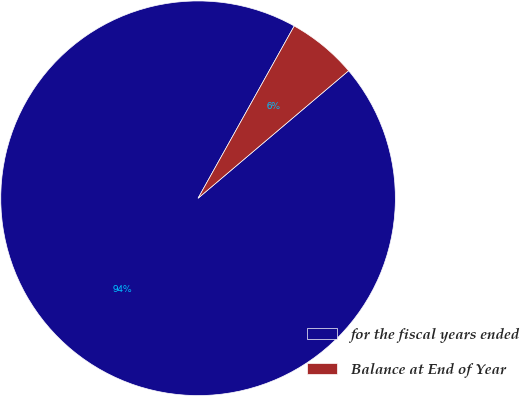Convert chart. <chart><loc_0><loc_0><loc_500><loc_500><pie_chart><fcel>for the fiscal years ended<fcel>Balance at End of Year<nl><fcel>94.29%<fcel>5.71%<nl></chart> 